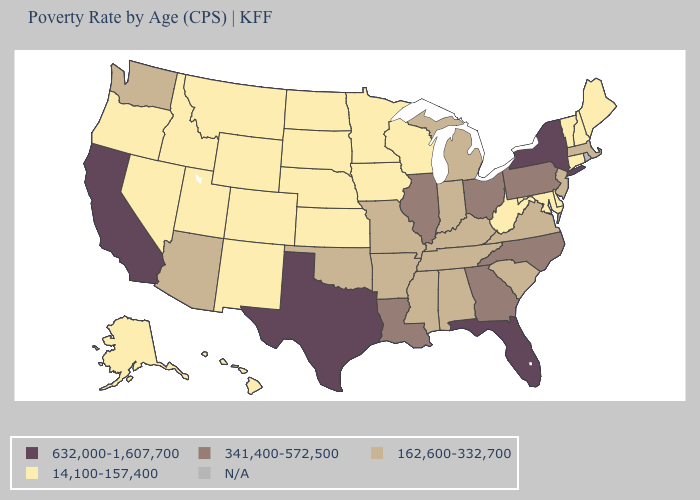What is the lowest value in states that border Iowa?
Quick response, please. 14,100-157,400. What is the lowest value in the USA?
Answer briefly. 14,100-157,400. Is the legend a continuous bar?
Answer briefly. No. What is the value of Rhode Island?
Keep it brief. N/A. What is the value of Nevada?
Short answer required. 14,100-157,400. Name the states that have a value in the range N/A?
Answer briefly. Rhode Island. Name the states that have a value in the range N/A?
Keep it brief. Rhode Island. What is the value of Iowa?
Give a very brief answer. 14,100-157,400. Which states hav the highest value in the MidWest?
Be succinct. Illinois, Ohio. What is the value of Utah?
Concise answer only. 14,100-157,400. What is the value of Connecticut?
Short answer required. 14,100-157,400. Name the states that have a value in the range 14,100-157,400?
Answer briefly. Alaska, Colorado, Connecticut, Delaware, Hawaii, Idaho, Iowa, Kansas, Maine, Maryland, Minnesota, Montana, Nebraska, Nevada, New Hampshire, New Mexico, North Dakota, Oregon, South Dakota, Utah, Vermont, West Virginia, Wisconsin, Wyoming. What is the value of Michigan?
Write a very short answer. 162,600-332,700. 